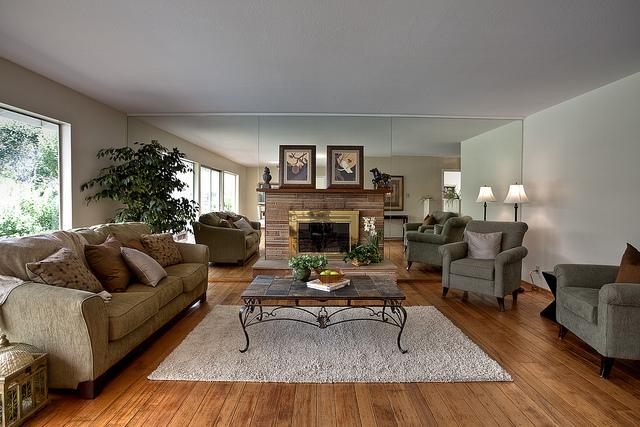What is the gold framed area against the back wall used to hold? fire 